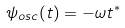<formula> <loc_0><loc_0><loc_500><loc_500>\psi _ { o s c } ( t ) = - \omega t ^ { \ast }</formula> 